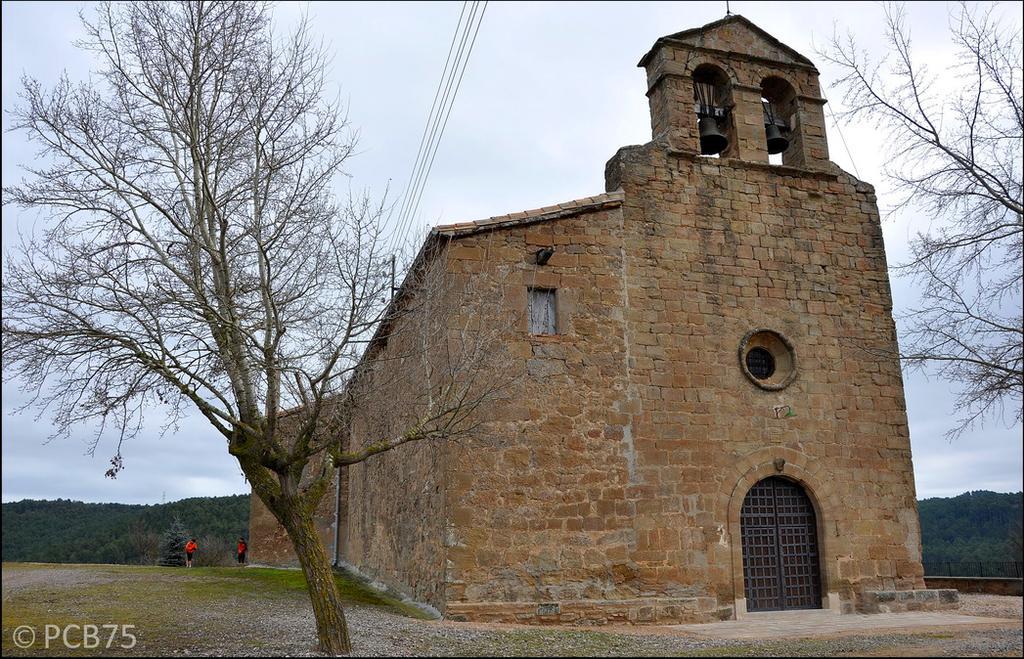Describe this image in one or two sentences. In this image we can see a building which is having two beers, a window and an entrance door. There are many trees in the image. There are two persons in the image. 